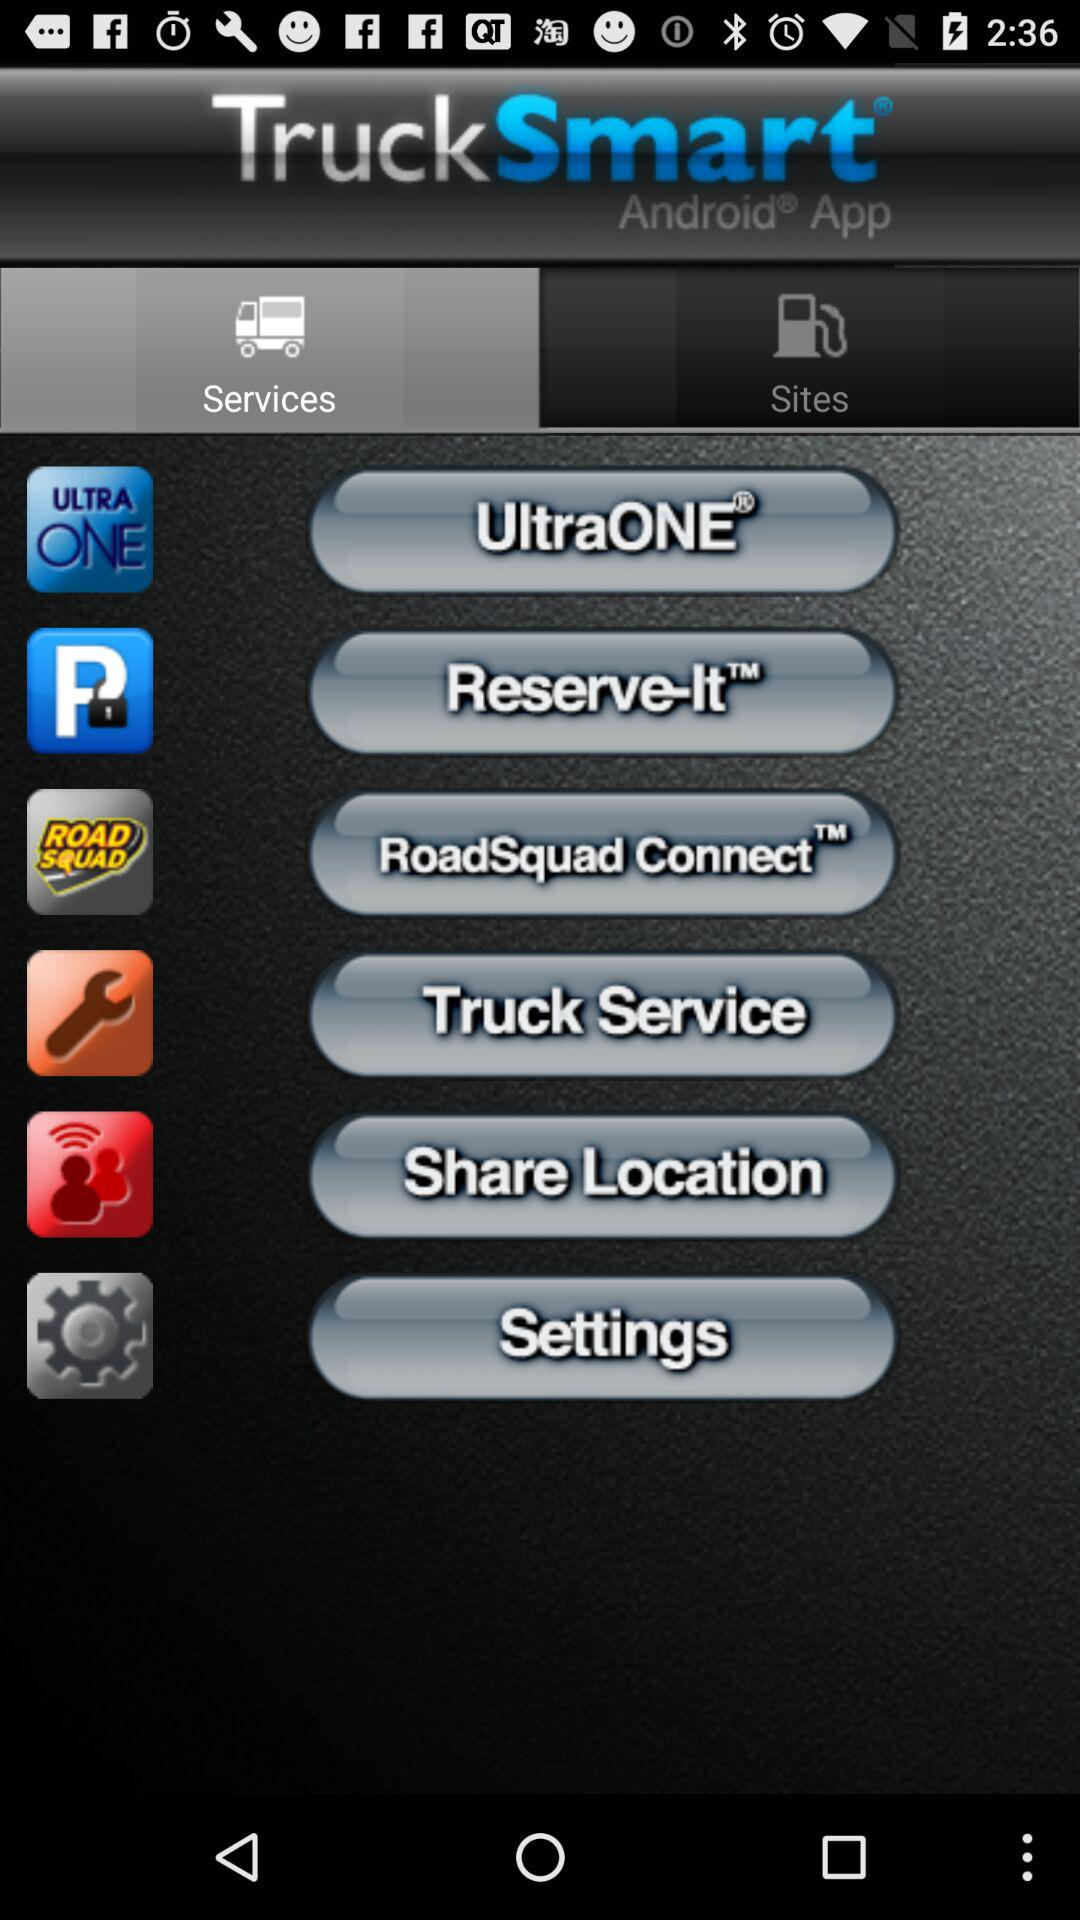Which tab is selected? The selected tab is "Services". 